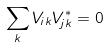<formula> <loc_0><loc_0><loc_500><loc_500>\sum _ { k } V _ { i k } V _ { j k } ^ { * } = 0</formula> 